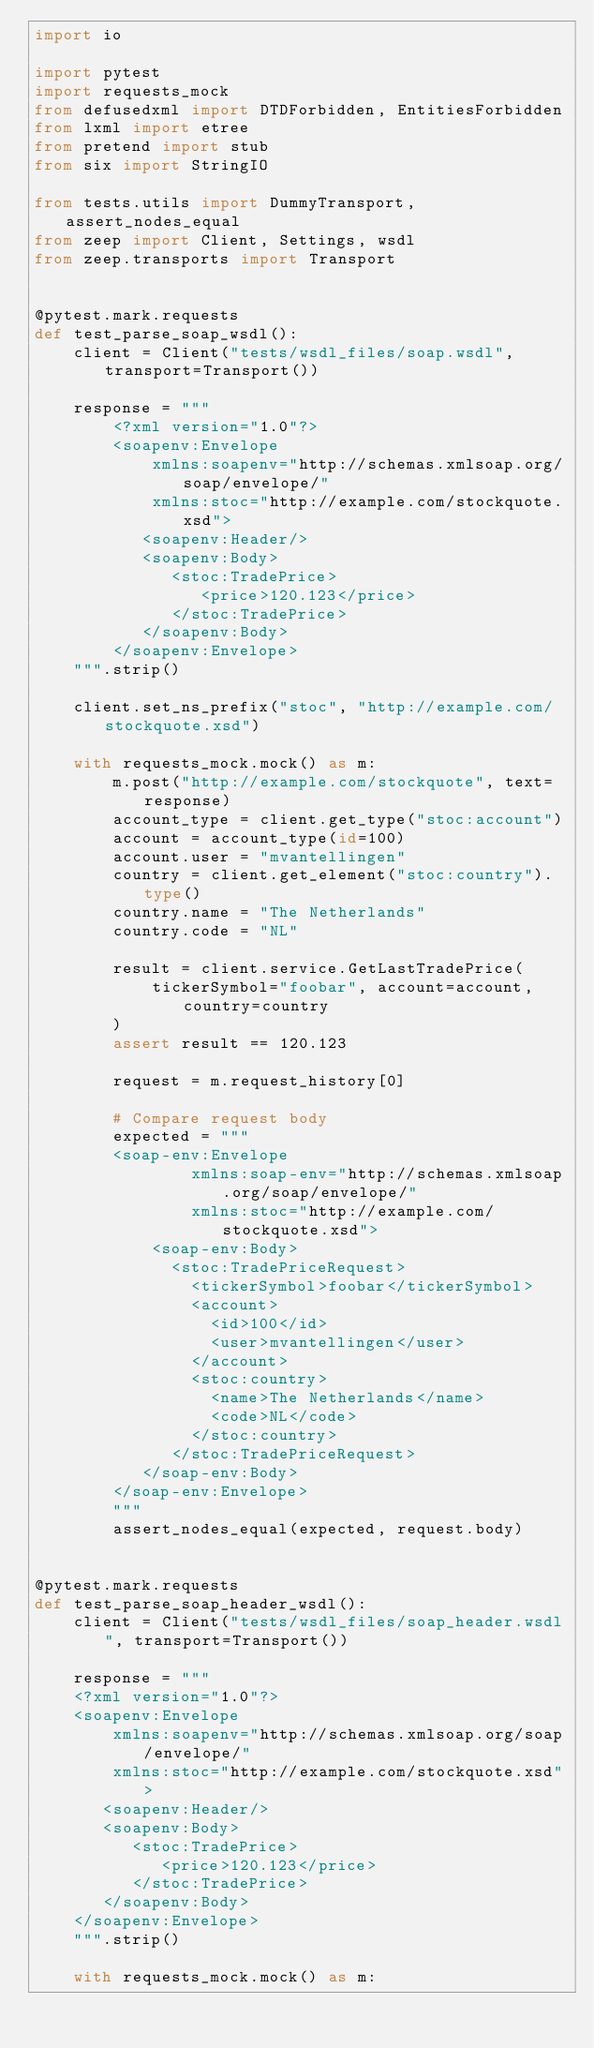<code> <loc_0><loc_0><loc_500><loc_500><_Python_>import io

import pytest
import requests_mock
from defusedxml import DTDForbidden, EntitiesForbidden
from lxml import etree
from pretend import stub
from six import StringIO

from tests.utils import DummyTransport, assert_nodes_equal
from zeep import Client, Settings, wsdl
from zeep.transports import Transport


@pytest.mark.requests
def test_parse_soap_wsdl():
    client = Client("tests/wsdl_files/soap.wsdl", transport=Transport())

    response = """
        <?xml version="1.0"?>
        <soapenv:Envelope
            xmlns:soapenv="http://schemas.xmlsoap.org/soap/envelope/"
            xmlns:stoc="http://example.com/stockquote.xsd">
           <soapenv:Header/>
           <soapenv:Body>
              <stoc:TradePrice>
                 <price>120.123</price>
              </stoc:TradePrice>
           </soapenv:Body>
        </soapenv:Envelope>
    """.strip()

    client.set_ns_prefix("stoc", "http://example.com/stockquote.xsd")

    with requests_mock.mock() as m:
        m.post("http://example.com/stockquote", text=response)
        account_type = client.get_type("stoc:account")
        account = account_type(id=100)
        account.user = "mvantellingen"
        country = client.get_element("stoc:country").type()
        country.name = "The Netherlands"
        country.code = "NL"

        result = client.service.GetLastTradePrice(
            tickerSymbol="foobar", account=account, country=country
        )
        assert result == 120.123

        request = m.request_history[0]

        # Compare request body
        expected = """
        <soap-env:Envelope
                xmlns:soap-env="http://schemas.xmlsoap.org/soap/envelope/"
                xmlns:stoc="http://example.com/stockquote.xsd">
            <soap-env:Body>
              <stoc:TradePriceRequest>
                <tickerSymbol>foobar</tickerSymbol>
                <account>
                  <id>100</id>
                  <user>mvantellingen</user>
                </account>
                <stoc:country>
                  <name>The Netherlands</name>
                  <code>NL</code>
                </stoc:country>
              </stoc:TradePriceRequest>
           </soap-env:Body>
        </soap-env:Envelope>
        """
        assert_nodes_equal(expected, request.body)


@pytest.mark.requests
def test_parse_soap_header_wsdl():
    client = Client("tests/wsdl_files/soap_header.wsdl", transport=Transport())

    response = """
    <?xml version="1.0"?>
    <soapenv:Envelope
        xmlns:soapenv="http://schemas.xmlsoap.org/soap/envelope/"
        xmlns:stoc="http://example.com/stockquote.xsd">
       <soapenv:Header/>
       <soapenv:Body>
          <stoc:TradePrice>
             <price>120.123</price>
          </stoc:TradePrice>
       </soapenv:Body>
    </soapenv:Envelope>
    """.strip()

    with requests_mock.mock() as m:</code> 